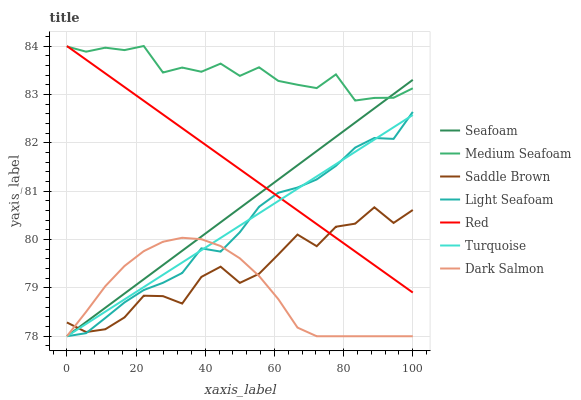Does Dark Salmon have the minimum area under the curve?
Answer yes or no. Yes. Does Medium Seafoam have the maximum area under the curve?
Answer yes or no. Yes. Does Seafoam have the minimum area under the curve?
Answer yes or no. No. Does Seafoam have the maximum area under the curve?
Answer yes or no. No. Is Seafoam the smoothest?
Answer yes or no. Yes. Is Saddle Brown the roughest?
Answer yes or no. Yes. Is Medium Seafoam the smoothest?
Answer yes or no. No. Is Medium Seafoam the roughest?
Answer yes or no. No. Does Turquoise have the lowest value?
Answer yes or no. Yes. Does Medium Seafoam have the lowest value?
Answer yes or no. No. Does Red have the highest value?
Answer yes or no. Yes. Does Seafoam have the highest value?
Answer yes or no. No. Is Turquoise less than Medium Seafoam?
Answer yes or no. Yes. Is Red greater than Dark Salmon?
Answer yes or no. Yes. Does Seafoam intersect Red?
Answer yes or no. Yes. Is Seafoam less than Red?
Answer yes or no. No. Is Seafoam greater than Red?
Answer yes or no. No. Does Turquoise intersect Medium Seafoam?
Answer yes or no. No. 